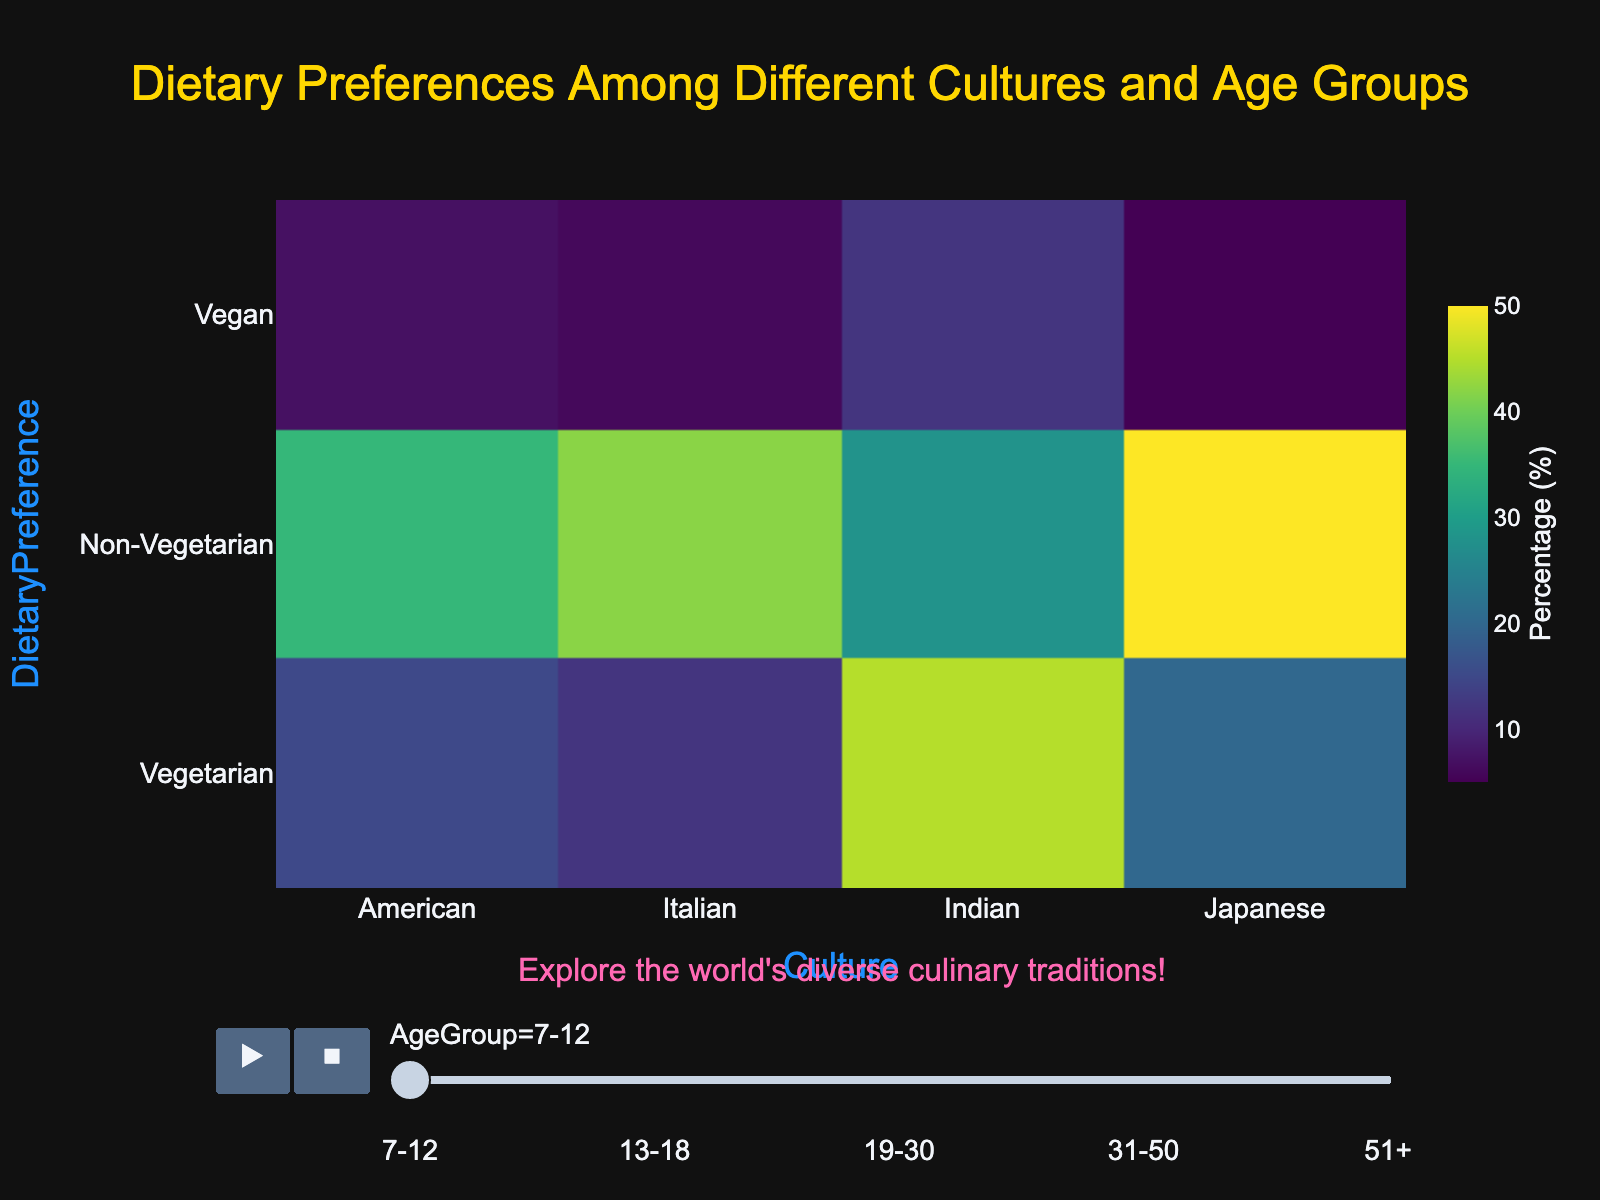What title is displayed on the figure? The title of the figure is usually displayed at the top center of the plot in the largest font size.
Answer: Dietary Preferences Among Different Cultures and Age Groups Which age group shows the highest preference for vegetarianism in Indian culture? Scan through the age groups and observe the intensity of the density for vegetarianism under Indian culture. The age group with the highest density or darkest color would indicate the highest preference.
Answer: 31-50 How does the percentage of Vegan preferences in American culture compare between the 19-30 and 31-50 age groups? Check the percentages of Vegan preferences in the American culture for both 19-30 and 31-50 age groups and compare them.
Answer: 10 vs 15 What cultural group has the highest percentage of non-vegetarian preferences among 13-18-year-olds? Inspect the density for non-vegetarian preferences across all cultures for 13-18-year-olds and identify the one with the highest density.
Answer: Japanese What does the density heatmap's color scale represent? Color scales in density heatmaps represent varying intensities, with certain colors indicating higher percentages and others indicating lower percentages.
Answer: Percentage (%) Which age group in Italian culture has the lowest percentage for Vegetarian preferences? Locate the sections for Italian culture and compare the percentages for Vegetarian preferences across all the age groups to find the lowest.
Answer: 7-12 What is the difference in percentage points between Non-Vegetarian and Vegan preferences in Japanese culture among 51+ age group? Subtract the percentage of Vegan preferences from the Non-Vegetarian preferences within Japanese culture for the 51+ age group.
Answer: 50 - 10 = 40 Among the American culture, which age group has the highest preference for vegan diets? Review the subsections for American culture and compare the percentages for Vegan diets across all age groups to find the highest.
Answer: 31-50 In the age group of 7-12, which culture has the highest percentage of Vegetarian preference? For the 7-12 age group, compare the densities for Vegetarian preferences across all cultures and select the one with the highest density.
Answer: Indian 